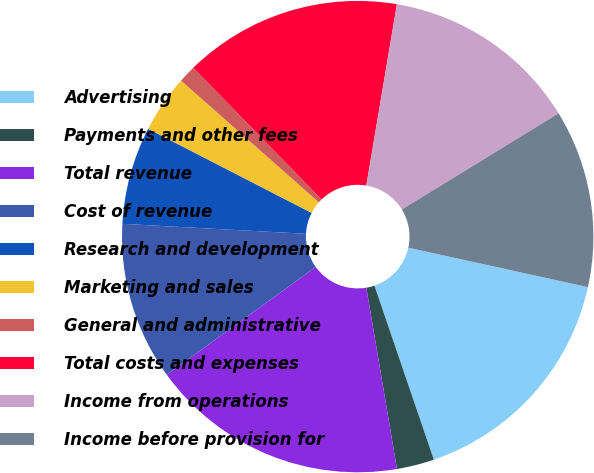Convert chart to OTSL. <chart><loc_0><loc_0><loc_500><loc_500><pie_chart><fcel>Advertising<fcel>Payments and other fees<fcel>Total revenue<fcel>Cost of revenue<fcel>Research and development<fcel>Marketing and sales<fcel>General and administrative<fcel>Total costs and expenses<fcel>Income from operations<fcel>Income before provision for<nl><fcel>16.33%<fcel>2.57%<fcel>17.7%<fcel>10.83%<fcel>6.7%<fcel>3.95%<fcel>1.2%<fcel>14.95%<fcel>13.58%<fcel>12.2%<nl></chart> 